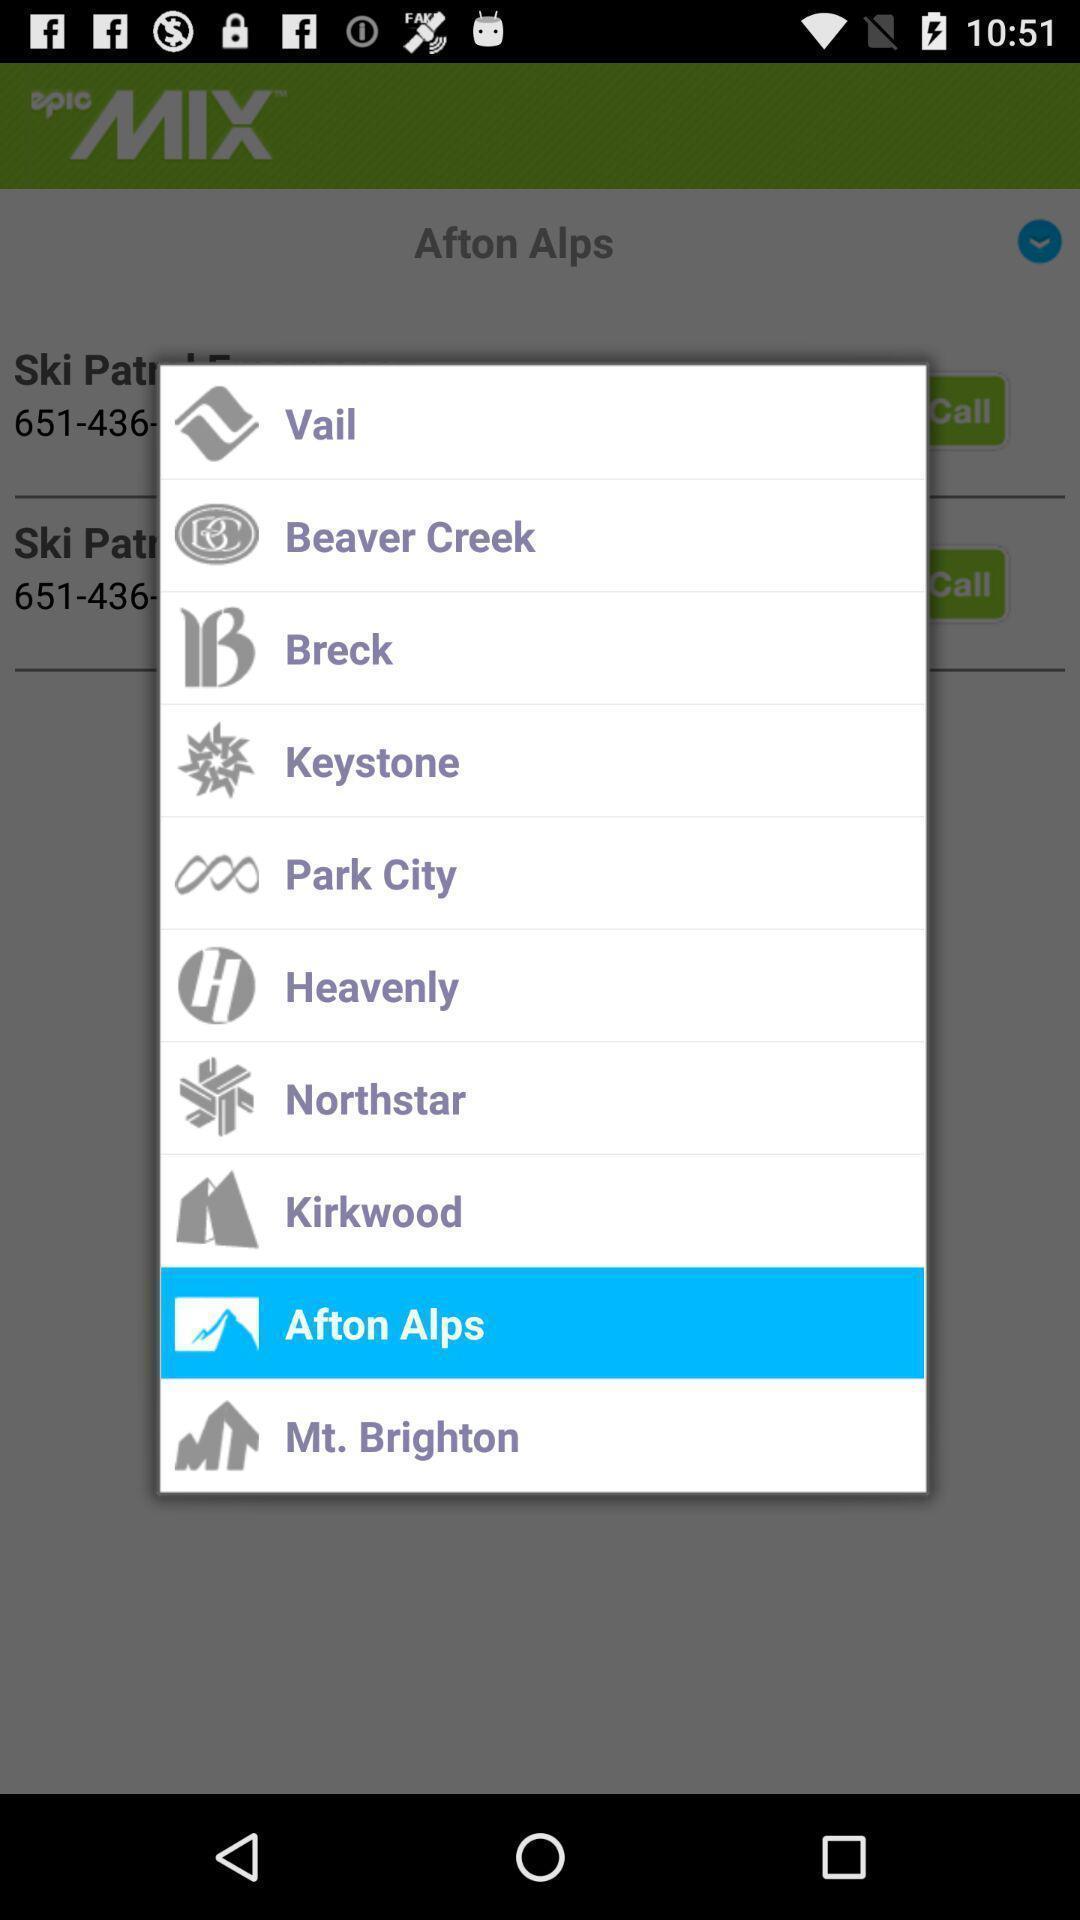Please provide a description for this image. Popup page with different logs and different brands. 